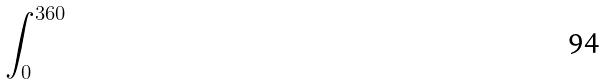Convert formula to latex. <formula><loc_0><loc_0><loc_500><loc_500>\int _ { 0 } ^ { 3 6 0 }</formula> 